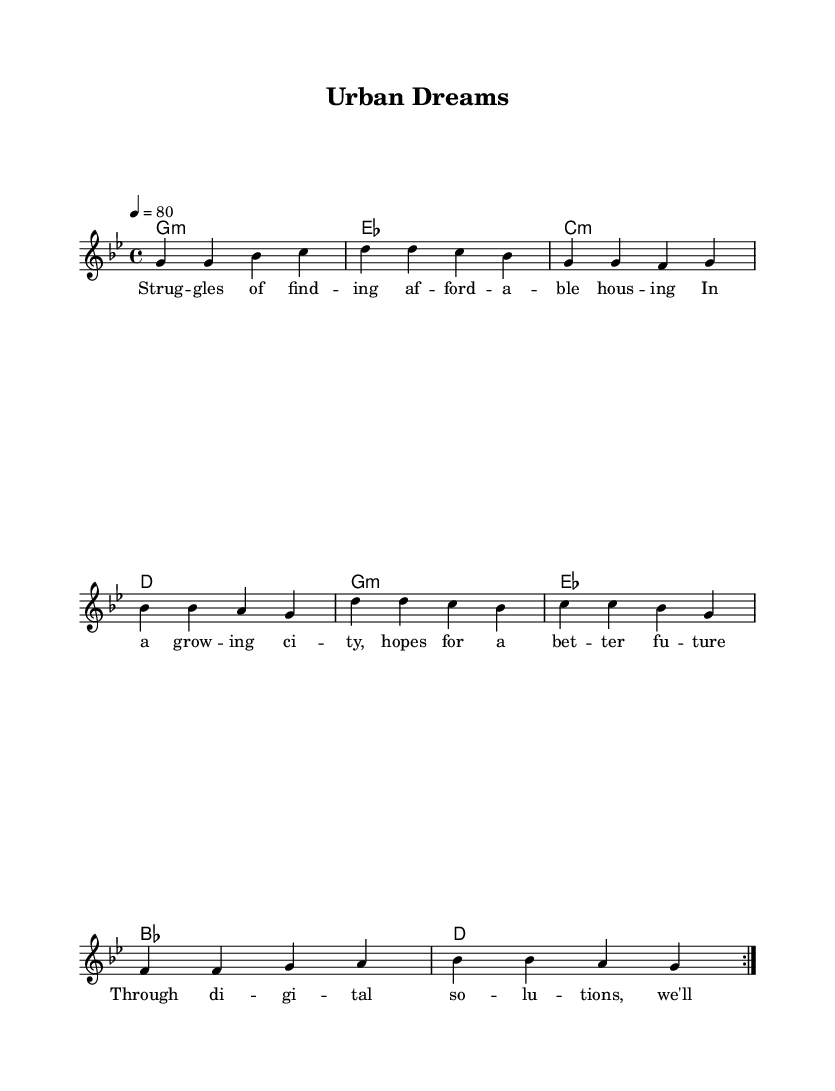What is the key signature of this music? The key signature is G minor, which contains two flats (B flat and E flat). This can be identified from the initial part of the score where the key signature is displayed.
Answer: G minor What is the tempo marking for this piece? The tempo marking indicated in the score is "4 = 80", which means there are 80 beats per minute, and each quarter note is counted as one beat. This can be found in the tempo text below the title.
Answer: 80 What type of chord primarily appears in the harmonies? The harmonies consist mostly of minor chords, indicated by the "m" in "g1:m" and "c:m". The presence of these "m" notations indicates the minor quality of the chords used throughout the piece.
Answer: Minor How many verses are in the lyrics? The lyrics given contain one complete verse that reflects the struggles of finding affordable housing, which is repeated to match the melody structure. This is evident as there is only one section provided under "verse_lyrics."
Answer: One What musical form does this piece exemplify? The score uses a repeated section with volta (first and second endings) which suggests a simple verse format commonly found in contemporary R&B songs. The structure leads to the same musical phrases being played multiple times.
Answer: Verse form What genre of music does this piece represent? The piece is categorized as contemporary R&B, due to its stylistic elements that focus on themes relevant to urban challenges such as affordable housing, characterized in both the music and lyrics.
Answer: Contemporary R&B 